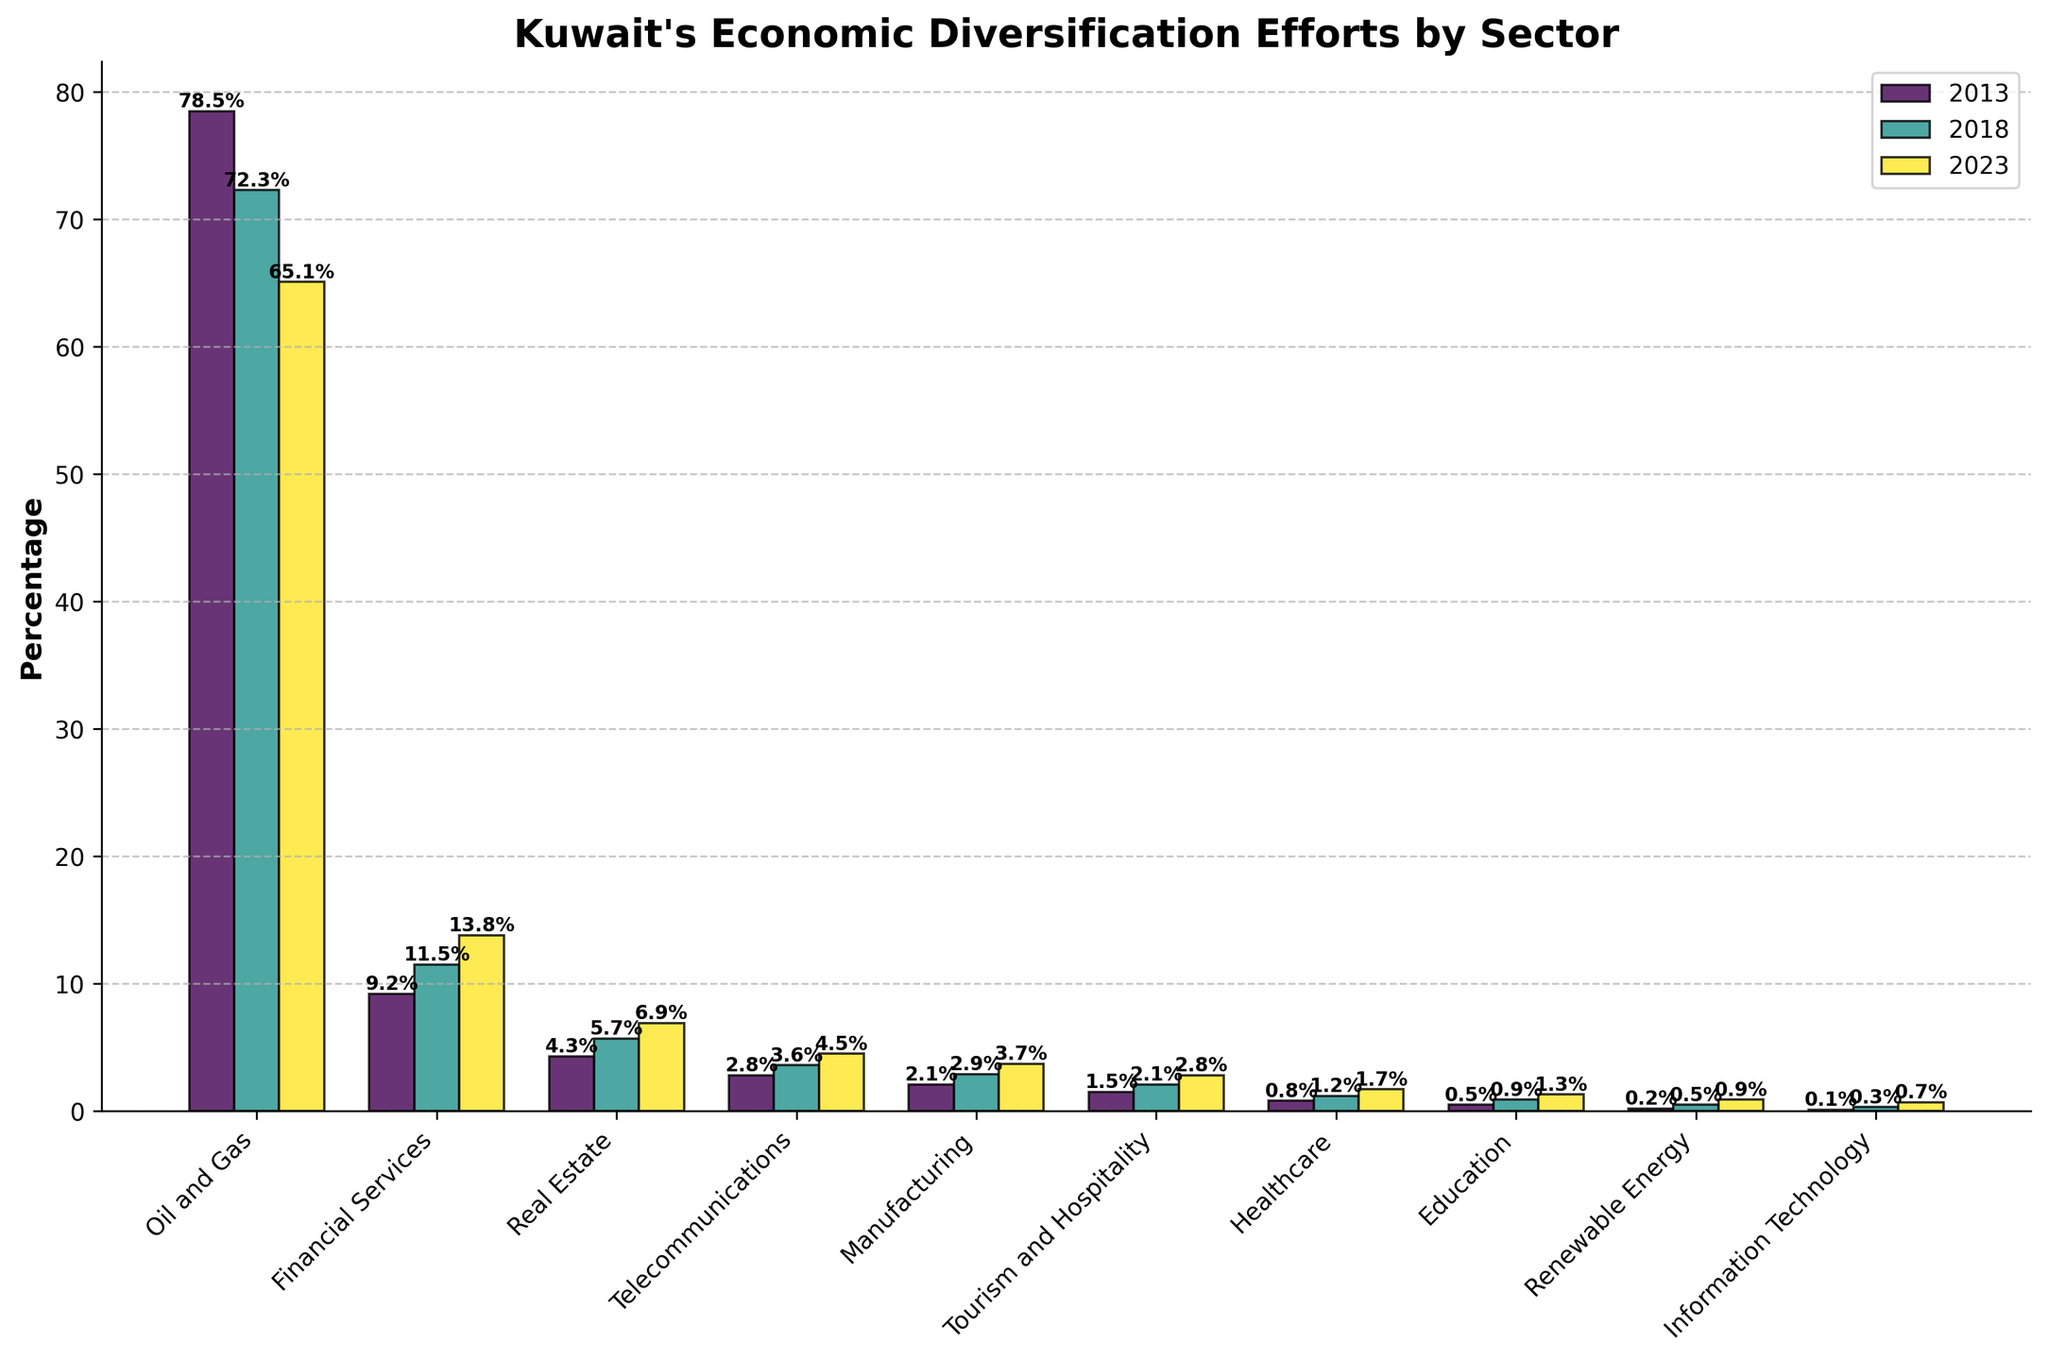what's the sector with the highest percentage decrease in share from 2013 to 2023? To determine the sector with the highest percentage decrease, subtract the 2023 value from the 2013 value for each sector. Then, find the sector with the highest difference. The largest decrease is seen in the "Oil and Gas" sector, which decreased from 78.5% in 2013 to 65.1% in 2023, resulting in a decrease of 13.4%.
Answer: Oil and Gas which sector experienced the greatest absolute increase in share from 2013 to 2023? For absolute increase, subtract the 2013 value from the 2023 value for each sector. The greatest absolute increase is in "Financial Services," which increased from 9.2% in 2013 to 13.8% in 2023, resulting in an increase of 4.6%.
Answer: Financial Services which sectors have consistent growth over the three years? Growth consistency means each sector must show an increase from 2013 to 2018 and then from 2018 to 2023. The sectors exhibiting consistent growth are: "Financial Services," "Real Estate," "Telecommunications," "Manufacturing," "Tourism and Hospitality," "Healthcare," "Education," "Renewable Energy," and "Information Technology."
Answer: Financial Services, Real Estate, Telecommunications, Manufacturing, Tourism and Hospitality, Healthcare, Education, Renewable Energy, Information Technology how many sectors had a percentage share below 5% in 2013 but above 5% in 2023? To find this, compare the values for each sector in 2013 and 2023 against the 5% threshold. "Real Estate" and "Financial Services" fit the criteria, being below 5% in 2013 and above 5% in 2023.
Answer: 2 what's the total percentage share for non-oil and gas sectors in 2023? Add up the percentage shares of all sectors except "Oil and Gas" in 2023: 13.8% (Financial Services) + 6.9% (Real Estate) + 4.5% (Telecommunications) + 3.7% (Manufacturing) + 2.8% (Tourism and Hospitality) + 1.7% (Healthcare) + 1.3% (Education) + 0.9% (Renewable Energy) + 0.7% (Information Technology) = 36.3%.
Answer: 36.3% how does the growth rate of the "Renewable Energy" sector from 2018 to 2023 compare to its growth rate from 2013 to 2018? Calculate both growth rates as follows: From 2013 to 2018: (0.5 - 0.2) / 0.2 = 1.5 or 150%. From 2018 to 2023: (0.9 - 0.5) / 0.5 = 0.8 or 80%. The growth rate from 2013 to 2018 is higher.
Answer: Higher from 2013 to 2018 which sector had the closest percentage share to "Telecommunications" in 2023? Look at the 2023 values for all sectors and find the one closest to 4.5% (Telecommunications). The "Manufacturing" sector, which has a share of 3.7% in 2023, is the closest.
Answer: Manufacturing what is the sum of percentage shares for "Healthcare", "Education", and "Renewable Energy" in 2023? Add the 2023 percentage values: 1.7% (Healthcare) + 1.3% (Education) + 0.9% (Renewable Energy) = 3.9%.
Answer: 3.9% how many sectors had their share increase by more than 1% from 2013 to 2023? Calculate the difference between 2023 and 2013 values for each sector. The sectors with an increase of more than 1% are "Financial Services" (4.6%), "Real Estate" (2.6%), and "Telecommunications" (1.7%).
Answer: 3 